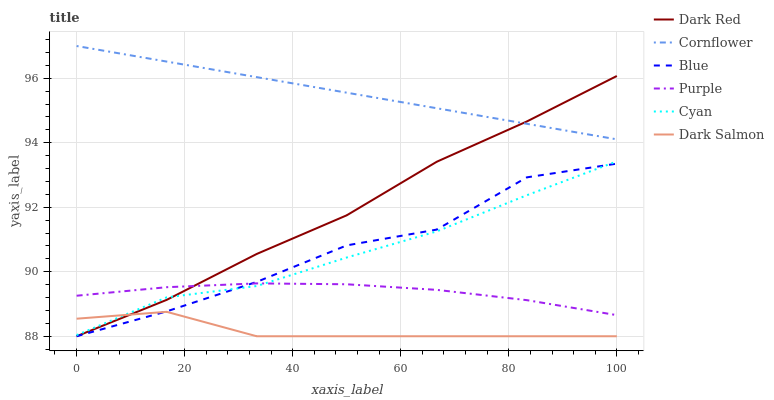Does Dark Salmon have the minimum area under the curve?
Answer yes or no. Yes. Does Cornflower have the maximum area under the curve?
Answer yes or no. Yes. Does Purple have the minimum area under the curve?
Answer yes or no. No. Does Purple have the maximum area under the curve?
Answer yes or no. No. Is Cornflower the smoothest?
Answer yes or no. Yes. Is Blue the roughest?
Answer yes or no. Yes. Is Purple the smoothest?
Answer yes or no. No. Is Purple the roughest?
Answer yes or no. No. Does Blue have the lowest value?
Answer yes or no. Yes. Does Purple have the lowest value?
Answer yes or no. No. Does Cornflower have the highest value?
Answer yes or no. Yes. Does Purple have the highest value?
Answer yes or no. No. Is Purple less than Cornflower?
Answer yes or no. Yes. Is Cornflower greater than Cyan?
Answer yes or no. Yes. Does Cyan intersect Purple?
Answer yes or no. Yes. Is Cyan less than Purple?
Answer yes or no. No. Is Cyan greater than Purple?
Answer yes or no. No. Does Purple intersect Cornflower?
Answer yes or no. No. 